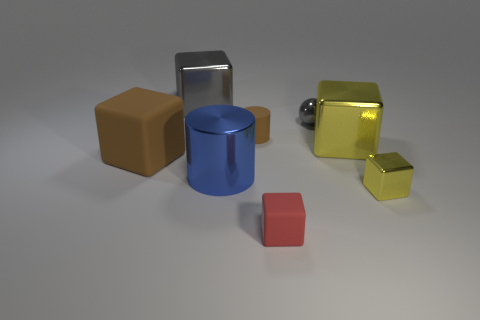Subtract all red matte cubes. How many cubes are left? 4 Subtract all red blocks. How many blocks are left? 4 Subtract 1 blocks. How many blocks are left? 4 Subtract all blue blocks. Subtract all cyan balls. How many blocks are left? 5 Subtract all blocks. How many objects are left? 3 Add 1 big rubber cubes. How many objects exist? 9 Add 4 small blocks. How many small blocks are left? 6 Add 5 yellow metallic blocks. How many yellow metallic blocks exist? 7 Subtract 1 blue cylinders. How many objects are left? 7 Subtract all small brown cylinders. Subtract all tiny rubber blocks. How many objects are left? 6 